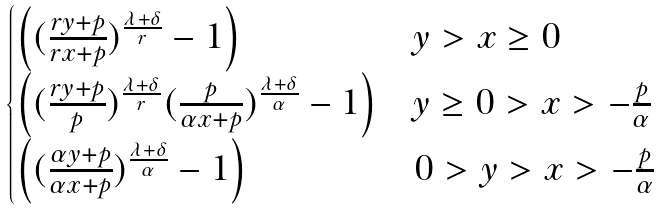Convert formula to latex. <formula><loc_0><loc_0><loc_500><loc_500>\begin{cases} \left ( ( \frac { r y + p } { r x + p } ) ^ { \frac { \lambda + \delta } { r } } - 1 \right ) & y > x \geq 0 \\ \left ( ( \frac { r y + p } { p } ) ^ { \frac { \lambda + \delta } { r } } ( \frac { p } { \alpha x + p } ) ^ { \frac { \lambda + \delta } { \alpha } } - 1 \right ) & y \geq 0 > x > - \frac { p } { \alpha } \\ \left ( ( \frac { \alpha y + p } { \alpha x + p } ) ^ { \frac { \lambda + \delta } { \alpha } } - 1 \right ) & 0 > y > x > - \frac { p } { \alpha } \end{cases}</formula> 